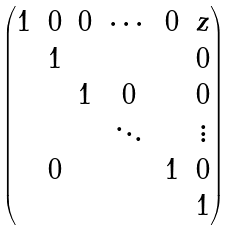<formula> <loc_0><loc_0><loc_500><loc_500>\begin{pmatrix} 1 & 0 & 0 & \cdots & 0 & z \\ & 1 & & & & 0 \\ & & 1 & 0 & & 0 \\ & & & \ddots & & \vdots \\ & 0 & & & 1 & 0 \\ & & & & & 1 \end{pmatrix}</formula> 